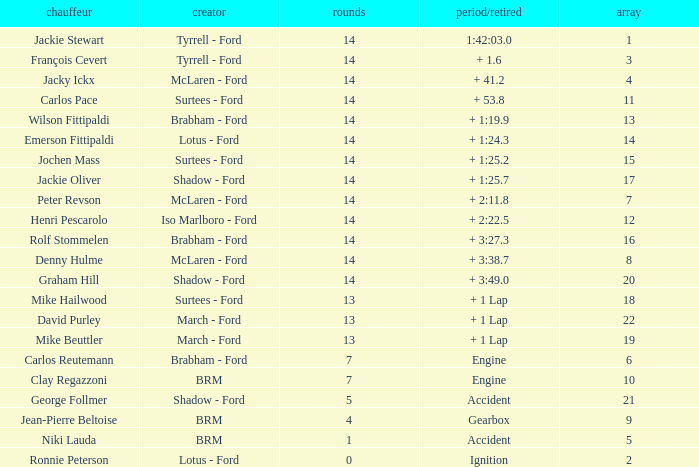What is the low lap total for henri pescarolo with a grad larger than 6? 14.0. 